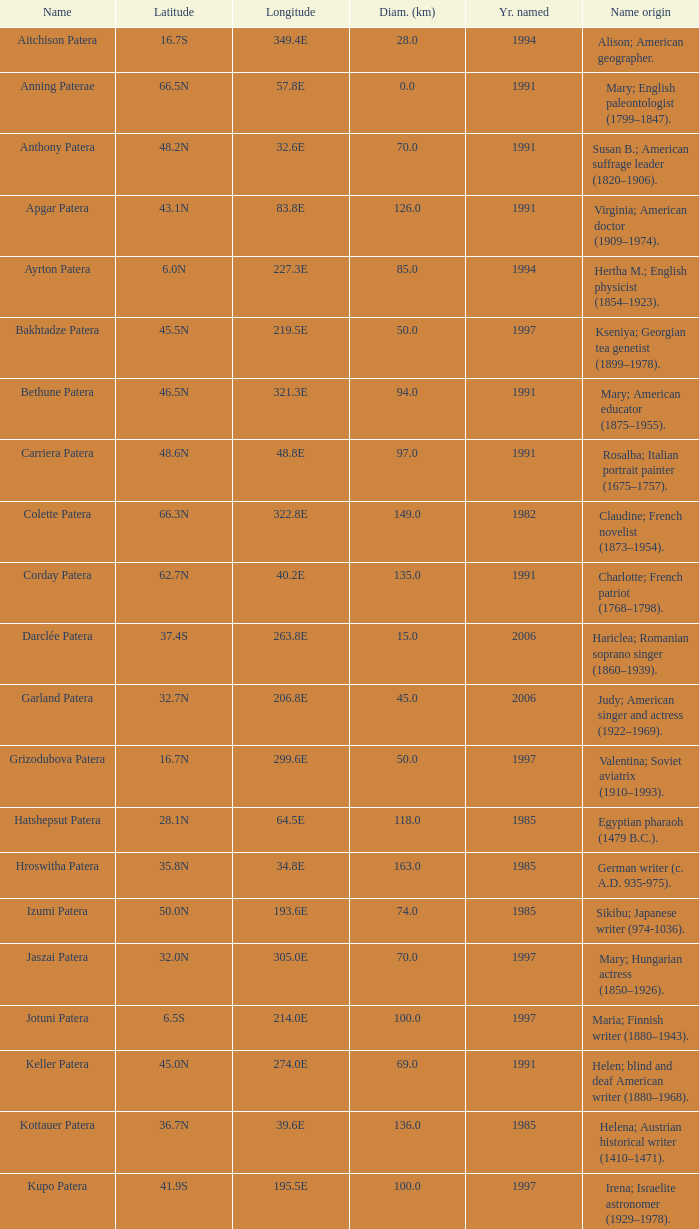What is the origin of the name of Keller Patera?  Helen; blind and deaf American writer (1880–1968). Help me parse the entirety of this table. {'header': ['Name', 'Latitude', 'Longitude', 'Diam. (km)', 'Yr. named', 'Name origin'], 'rows': [['Aitchison Patera', '16.7S', '349.4E', '28.0', '1994', 'Alison; American geographer.'], ['Anning Paterae', '66.5N', '57.8E', '0.0', '1991', 'Mary; English paleontologist (1799–1847).'], ['Anthony Patera', '48.2N', '32.6E', '70.0', '1991', 'Susan B.; American suffrage leader (1820–1906).'], ['Apgar Patera', '43.1N', '83.8E', '126.0', '1991', 'Virginia; American doctor (1909–1974).'], ['Ayrton Patera', '6.0N', '227.3E', '85.0', '1994', 'Hertha M.; English physicist (1854–1923).'], ['Bakhtadze Patera', '45.5N', '219.5E', '50.0', '1997', 'Kseniya; Georgian tea genetist (1899–1978).'], ['Bethune Patera', '46.5N', '321.3E', '94.0', '1991', 'Mary; American educator (1875–1955).'], ['Carriera Patera', '48.6N', '48.8E', '97.0', '1991', 'Rosalba; Italian portrait painter (1675–1757).'], ['Colette Patera', '66.3N', '322.8E', '149.0', '1982', 'Claudine; French novelist (1873–1954).'], ['Corday Patera', '62.7N', '40.2E', '135.0', '1991', 'Charlotte; French patriot (1768–1798).'], ['Darclée Patera', '37.4S', '263.8E', '15.0', '2006', 'Hariclea; Romanian soprano singer (1860–1939).'], ['Garland Patera', '32.7N', '206.8E', '45.0', '2006', 'Judy; American singer and actress (1922–1969).'], ['Grizodubova Patera', '16.7N', '299.6E', '50.0', '1997', 'Valentina; Soviet aviatrix (1910–1993).'], ['Hatshepsut Patera', '28.1N', '64.5E', '118.0', '1985', 'Egyptian pharaoh (1479 B.C.).'], ['Hroswitha Patera', '35.8N', '34.8E', '163.0', '1985', 'German writer (c. A.D. 935-975).'], ['Izumi Patera', '50.0N', '193.6E', '74.0', '1985', 'Sikibu; Japanese writer (974-1036).'], ['Jaszai Patera', '32.0N', '305.0E', '70.0', '1997', 'Mary; Hungarian actress (1850–1926).'], ['Jotuni Patera', '6.5S', '214.0E', '100.0', '1997', 'Maria; Finnish writer (1880–1943).'], ['Keller Patera', '45.0N', '274.0E', '69.0', '1991', 'Helen; blind and deaf American writer (1880–1968).'], ['Kottauer Patera', '36.7N', '39.6E', '136.0', '1985', 'Helena; Austrian historical writer (1410–1471).'], ['Kupo Patera', '41.9S', '195.5E', '100.0', '1997', 'Irena; Israelite astronomer (1929–1978).'], ['Ledoux Patera', '9.2S', '224.8E', '75.0', '1994', 'Jeanne; French artist (1767–1840).'], ['Lindgren Patera', '28.1N', '241.4E', '110.0', '2006', 'Astrid; Swedish author (1907–2002).'], ['Mehseti Patera', '16.0N', '311.0E', '60.0', '1997', 'Ganjevi; Azeri/Persian poet (c. 1050-c. 1100).'], ['Mezrina Patera', '33.3S', '68.8E', '60.0', '2000', 'Anna; Russian clay toy sculptor (1853–1938).'], ['Nordenflycht Patera', '35.0S', '266.0E', '140.0', '1997', 'Hedwig; Swedish poet (1718–1763).'], ['Panina Patera', '13.0S', '309.8E', '50.0', '1997', 'Varya; Gypsy/Russian singer (1872–1911).'], ['Payne-Gaposchkin Patera', '25.5S', '196.0E', '100.0', '1997', 'Cecilia Helena; American astronomer (1900–1979).'], ['Pocahontas Patera', '64.9N', '49.4E', '78.0', '1991', 'Powhatan Indian peacemaker (1595–1617).'], ['Raskova Paterae', '51.0S', '222.8E', '80.0', '1994', 'Marina M.; Russian aviator (1912–1943).'], ['Razia Patera', '46.2N', '197.8E', '157.0', '1985', 'Queen of Delhi Sultanate (India) (1236–1240).'], ['Shulzhenko Patera', '6.5N', '264.5E', '60.0', '1997', 'Klavdiya; Soviet singer (1906–1984).'], ['Siddons Patera', '61.6N', '340.6E', '47.0', '1997', 'Sarah; English actress (1755–1831).'], ['Stopes Patera', '42.6N', '46.5E', '169.0', '1991', 'Marie; English paleontologist (1880–1959).'], ['Tarbell Patera', '58.2S', '351.5E', '80.0', '1994', 'Ida; American author, editor (1857–1944).'], ['Teasdale Patera', '67.6S', '189.1E', '75.0', '1994', 'Sara; American poet (1884–1933).'], ['Tey Patera', '17.8S', '349.1E', '20.0', '1994', 'Josephine; Scottish author (1897–1952).'], ['Tipporah Patera', '38.9N', '43.0E', '99.0', '1985', 'Hebrew medical scholar (1500 B.C.).'], ['Vibert-Douglas Patera', '11.6S', '194.3E', '45.0', '2003', 'Allie; Canadian astronomer (1894–1988).'], ['Villepreux-Power Patera', '22.0S', '210.0E', '100.0', '1997', 'Jeannette; French marine biologist (1794–1871).'], ['Wilde Patera', '21.3S', '266.3E', '75.0', '2000', 'Lady Jane Francesca; Irish poet (1821–1891).'], ['Witte Patera', '25.8S', '247.65E', '35.0', '2006', 'Wilhelmine; German astronomer (1777–1854).'], ['Woodhull Patera', '37.4N', '305.4E', '83.0', '1991', 'Victoria; American-English lecturer (1838–1927).']]} 